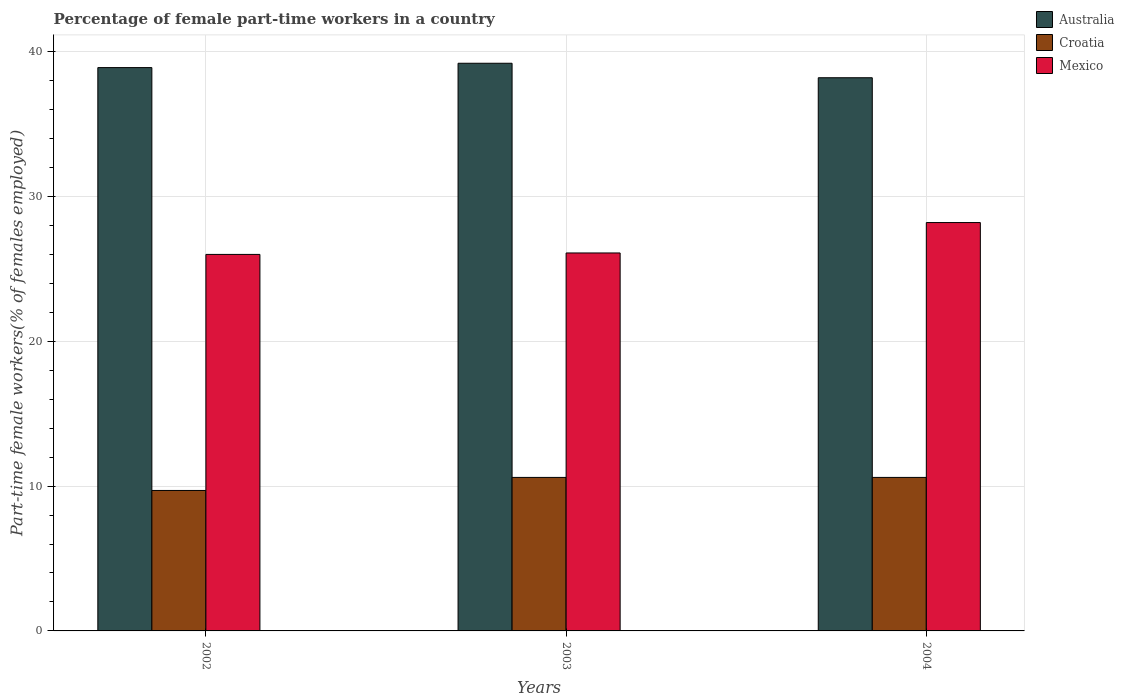How many groups of bars are there?
Your answer should be very brief. 3. Are the number of bars per tick equal to the number of legend labels?
Your answer should be very brief. Yes. Are the number of bars on each tick of the X-axis equal?
Provide a short and direct response. Yes. How many bars are there on the 3rd tick from the left?
Your answer should be compact. 3. What is the label of the 3rd group of bars from the left?
Give a very brief answer. 2004. In how many cases, is the number of bars for a given year not equal to the number of legend labels?
Keep it short and to the point. 0. What is the percentage of female part-time workers in Mexico in 2002?
Provide a short and direct response. 26. Across all years, what is the maximum percentage of female part-time workers in Mexico?
Offer a terse response. 28.2. Across all years, what is the minimum percentage of female part-time workers in Australia?
Your response must be concise. 38.2. In which year was the percentage of female part-time workers in Mexico maximum?
Give a very brief answer. 2004. In which year was the percentage of female part-time workers in Mexico minimum?
Provide a short and direct response. 2002. What is the total percentage of female part-time workers in Croatia in the graph?
Give a very brief answer. 30.9. What is the difference between the percentage of female part-time workers in Australia in 2003 and that in 2004?
Provide a short and direct response. 1. What is the difference between the percentage of female part-time workers in Croatia in 2002 and the percentage of female part-time workers in Mexico in 2004?
Give a very brief answer. -18.5. What is the average percentage of female part-time workers in Australia per year?
Your answer should be very brief. 38.77. In the year 2003, what is the difference between the percentage of female part-time workers in Croatia and percentage of female part-time workers in Australia?
Your response must be concise. -28.6. In how many years, is the percentage of female part-time workers in Mexico greater than 10 %?
Give a very brief answer. 3. What is the ratio of the percentage of female part-time workers in Croatia in 2002 to that in 2004?
Your response must be concise. 0.92. Is the difference between the percentage of female part-time workers in Croatia in 2003 and 2004 greater than the difference between the percentage of female part-time workers in Australia in 2003 and 2004?
Give a very brief answer. No. What is the difference between the highest and the second highest percentage of female part-time workers in Croatia?
Your response must be concise. 0. What is the difference between the highest and the lowest percentage of female part-time workers in Australia?
Your response must be concise. 1. Is the sum of the percentage of female part-time workers in Croatia in 2002 and 2004 greater than the maximum percentage of female part-time workers in Mexico across all years?
Your answer should be compact. No. Is it the case that in every year, the sum of the percentage of female part-time workers in Croatia and percentage of female part-time workers in Australia is greater than the percentage of female part-time workers in Mexico?
Ensure brevity in your answer.  Yes. How many years are there in the graph?
Offer a terse response. 3. What is the difference between two consecutive major ticks on the Y-axis?
Give a very brief answer. 10. Does the graph contain grids?
Your response must be concise. Yes. Where does the legend appear in the graph?
Your answer should be very brief. Top right. What is the title of the graph?
Offer a very short reply. Percentage of female part-time workers in a country. What is the label or title of the X-axis?
Your answer should be compact. Years. What is the label or title of the Y-axis?
Your response must be concise. Part-time female workers(% of females employed). What is the Part-time female workers(% of females employed) in Australia in 2002?
Provide a succinct answer. 38.9. What is the Part-time female workers(% of females employed) in Croatia in 2002?
Your response must be concise. 9.7. What is the Part-time female workers(% of females employed) of Mexico in 2002?
Ensure brevity in your answer.  26. What is the Part-time female workers(% of females employed) in Australia in 2003?
Ensure brevity in your answer.  39.2. What is the Part-time female workers(% of females employed) of Croatia in 2003?
Ensure brevity in your answer.  10.6. What is the Part-time female workers(% of females employed) of Mexico in 2003?
Provide a short and direct response. 26.1. What is the Part-time female workers(% of females employed) of Australia in 2004?
Offer a terse response. 38.2. What is the Part-time female workers(% of females employed) of Croatia in 2004?
Keep it short and to the point. 10.6. What is the Part-time female workers(% of females employed) in Mexico in 2004?
Make the answer very short. 28.2. Across all years, what is the maximum Part-time female workers(% of females employed) in Australia?
Provide a succinct answer. 39.2. Across all years, what is the maximum Part-time female workers(% of females employed) of Croatia?
Your response must be concise. 10.6. Across all years, what is the maximum Part-time female workers(% of females employed) in Mexico?
Keep it short and to the point. 28.2. Across all years, what is the minimum Part-time female workers(% of females employed) in Australia?
Offer a terse response. 38.2. Across all years, what is the minimum Part-time female workers(% of females employed) in Croatia?
Your answer should be compact. 9.7. Across all years, what is the minimum Part-time female workers(% of females employed) of Mexico?
Ensure brevity in your answer.  26. What is the total Part-time female workers(% of females employed) in Australia in the graph?
Ensure brevity in your answer.  116.3. What is the total Part-time female workers(% of females employed) of Croatia in the graph?
Ensure brevity in your answer.  30.9. What is the total Part-time female workers(% of females employed) in Mexico in the graph?
Keep it short and to the point. 80.3. What is the difference between the Part-time female workers(% of females employed) in Australia in 2002 and that in 2004?
Ensure brevity in your answer.  0.7. What is the difference between the Part-time female workers(% of females employed) of Croatia in 2002 and that in 2004?
Your response must be concise. -0.9. What is the difference between the Part-time female workers(% of females employed) in Australia in 2002 and the Part-time female workers(% of females employed) in Croatia in 2003?
Provide a succinct answer. 28.3. What is the difference between the Part-time female workers(% of females employed) of Australia in 2002 and the Part-time female workers(% of females employed) of Mexico in 2003?
Provide a short and direct response. 12.8. What is the difference between the Part-time female workers(% of females employed) of Croatia in 2002 and the Part-time female workers(% of females employed) of Mexico in 2003?
Your answer should be compact. -16.4. What is the difference between the Part-time female workers(% of females employed) in Australia in 2002 and the Part-time female workers(% of females employed) in Croatia in 2004?
Make the answer very short. 28.3. What is the difference between the Part-time female workers(% of females employed) in Australia in 2002 and the Part-time female workers(% of females employed) in Mexico in 2004?
Provide a succinct answer. 10.7. What is the difference between the Part-time female workers(% of females employed) in Croatia in 2002 and the Part-time female workers(% of females employed) in Mexico in 2004?
Provide a short and direct response. -18.5. What is the difference between the Part-time female workers(% of females employed) of Australia in 2003 and the Part-time female workers(% of females employed) of Croatia in 2004?
Make the answer very short. 28.6. What is the difference between the Part-time female workers(% of females employed) in Croatia in 2003 and the Part-time female workers(% of females employed) in Mexico in 2004?
Offer a terse response. -17.6. What is the average Part-time female workers(% of females employed) of Australia per year?
Your answer should be very brief. 38.77. What is the average Part-time female workers(% of females employed) of Mexico per year?
Provide a succinct answer. 26.77. In the year 2002, what is the difference between the Part-time female workers(% of females employed) of Australia and Part-time female workers(% of females employed) of Croatia?
Offer a very short reply. 29.2. In the year 2002, what is the difference between the Part-time female workers(% of females employed) of Croatia and Part-time female workers(% of females employed) of Mexico?
Provide a short and direct response. -16.3. In the year 2003, what is the difference between the Part-time female workers(% of females employed) in Australia and Part-time female workers(% of females employed) in Croatia?
Your answer should be very brief. 28.6. In the year 2003, what is the difference between the Part-time female workers(% of females employed) in Croatia and Part-time female workers(% of females employed) in Mexico?
Your response must be concise. -15.5. In the year 2004, what is the difference between the Part-time female workers(% of females employed) of Australia and Part-time female workers(% of females employed) of Croatia?
Make the answer very short. 27.6. In the year 2004, what is the difference between the Part-time female workers(% of females employed) of Croatia and Part-time female workers(% of females employed) of Mexico?
Give a very brief answer. -17.6. What is the ratio of the Part-time female workers(% of females employed) in Croatia in 2002 to that in 2003?
Provide a succinct answer. 0.92. What is the ratio of the Part-time female workers(% of females employed) of Australia in 2002 to that in 2004?
Give a very brief answer. 1.02. What is the ratio of the Part-time female workers(% of females employed) in Croatia in 2002 to that in 2004?
Give a very brief answer. 0.92. What is the ratio of the Part-time female workers(% of females employed) in Mexico in 2002 to that in 2004?
Ensure brevity in your answer.  0.92. What is the ratio of the Part-time female workers(% of females employed) of Australia in 2003 to that in 2004?
Offer a very short reply. 1.03. What is the ratio of the Part-time female workers(% of females employed) of Mexico in 2003 to that in 2004?
Offer a terse response. 0.93. What is the difference between the highest and the second highest Part-time female workers(% of females employed) in Australia?
Offer a terse response. 0.3. What is the difference between the highest and the second highest Part-time female workers(% of females employed) in Croatia?
Your answer should be compact. 0. 